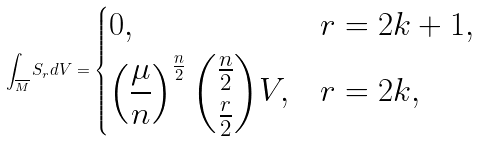<formula> <loc_0><loc_0><loc_500><loc_500>\int _ { \overline { M } } S _ { r } d V = \begin{dcases} 0 , & r = 2 k + 1 , \\ \left ( \frac { \mu } { n } \right ) ^ { \frac { n } { 2 } } \binom { \frac { n } { 2 } } { \frac { r } { 2 } } V , & r = 2 k , \end{dcases}</formula> 